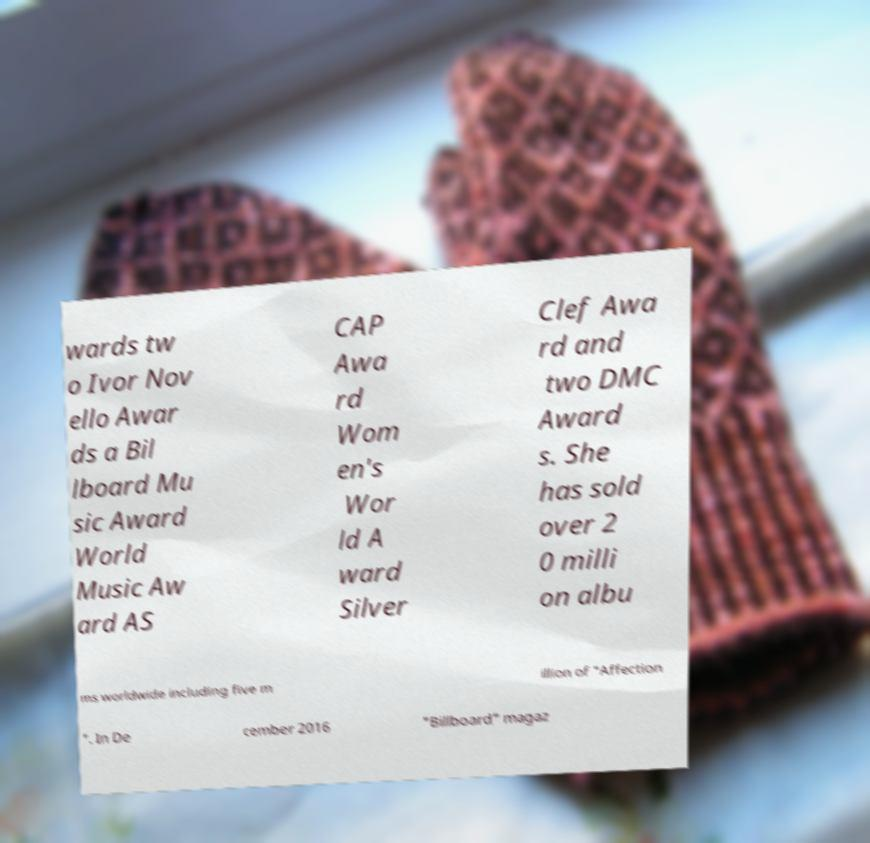Could you extract and type out the text from this image? wards tw o Ivor Nov ello Awar ds a Bil lboard Mu sic Award World Music Aw ard AS CAP Awa rd Wom en's Wor ld A ward Silver Clef Awa rd and two DMC Award s. She has sold over 2 0 milli on albu ms worldwide including five m illion of "Affection ". In De cember 2016 "Billboard" magaz 